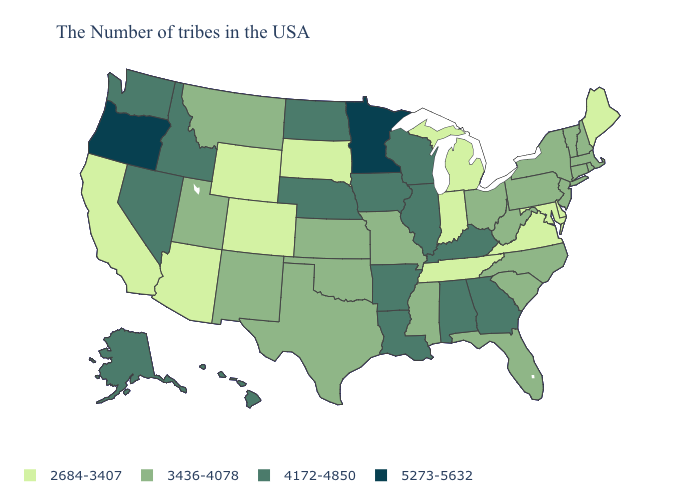Does Maine have the highest value in the Northeast?
Quick response, please. No. Name the states that have a value in the range 5273-5632?
Answer briefly. Minnesota, Oregon. What is the value of Montana?
Be succinct. 3436-4078. Which states hav the highest value in the West?
Be succinct. Oregon. How many symbols are there in the legend?
Concise answer only. 4. What is the lowest value in states that border Ohio?
Write a very short answer. 2684-3407. What is the highest value in states that border Connecticut?
Write a very short answer. 3436-4078. Name the states that have a value in the range 2684-3407?
Give a very brief answer. Maine, Delaware, Maryland, Virginia, Michigan, Indiana, Tennessee, South Dakota, Wyoming, Colorado, Arizona, California. Name the states that have a value in the range 3436-4078?
Short answer required. Massachusetts, Rhode Island, New Hampshire, Vermont, Connecticut, New York, New Jersey, Pennsylvania, North Carolina, South Carolina, West Virginia, Ohio, Florida, Mississippi, Missouri, Kansas, Oklahoma, Texas, New Mexico, Utah, Montana. What is the value of Wisconsin?
Concise answer only. 4172-4850. What is the value of Hawaii?
Be succinct. 4172-4850. What is the value of North Dakota?
Give a very brief answer. 4172-4850. Which states have the highest value in the USA?
Keep it brief. Minnesota, Oregon. Name the states that have a value in the range 5273-5632?
Answer briefly. Minnesota, Oregon. How many symbols are there in the legend?
Concise answer only. 4. 